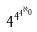<formula> <loc_0><loc_0><loc_500><loc_500>4 ^ { 4 ^ { 4 ^ { \aleph _ { 0 } } } }</formula> 